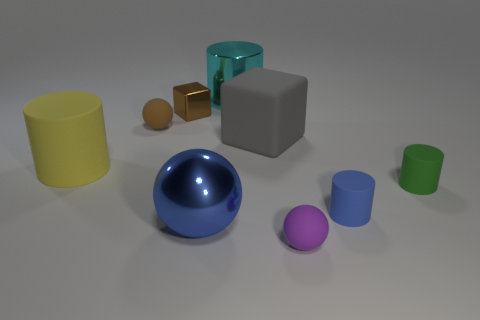Is there a purple object that has the same shape as the large yellow matte object?
Provide a short and direct response. No. What is the color of the cylinder that is the same size as the green object?
Offer a terse response. Blue. What number of objects are either big objects that are in front of the tiny brown sphere or tiny things that are behind the tiny brown rubber ball?
Give a very brief answer. 4. What number of things are tiny green shiny things or small brown metallic things?
Your answer should be compact. 1. There is a rubber thing that is left of the blue rubber cylinder and in front of the green matte cylinder; how big is it?
Offer a terse response. Small. What number of other cyan things are made of the same material as the large cyan object?
Provide a short and direct response. 0. There is another tiny object that is made of the same material as the cyan object; what color is it?
Offer a terse response. Brown. Does the cube on the right side of the metallic cylinder have the same color as the metal sphere?
Offer a terse response. No. There is a gray object behind the large yellow rubber cylinder; what is it made of?
Give a very brief answer. Rubber. Are there an equal number of yellow rubber things to the right of the small brown matte thing and small blue rubber cylinders?
Your answer should be compact. No. 